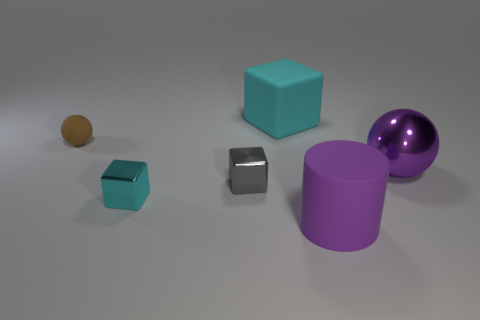Add 3 large blue spheres. How many objects exist? 9 Subtract all cylinders. How many objects are left? 5 Add 5 large matte cylinders. How many large matte cylinders are left? 6 Add 1 big gray metal things. How many big gray metal things exist? 1 Subtract 0 gray spheres. How many objects are left? 6 Subtract all large cyan matte cylinders. Subtract all large cubes. How many objects are left? 5 